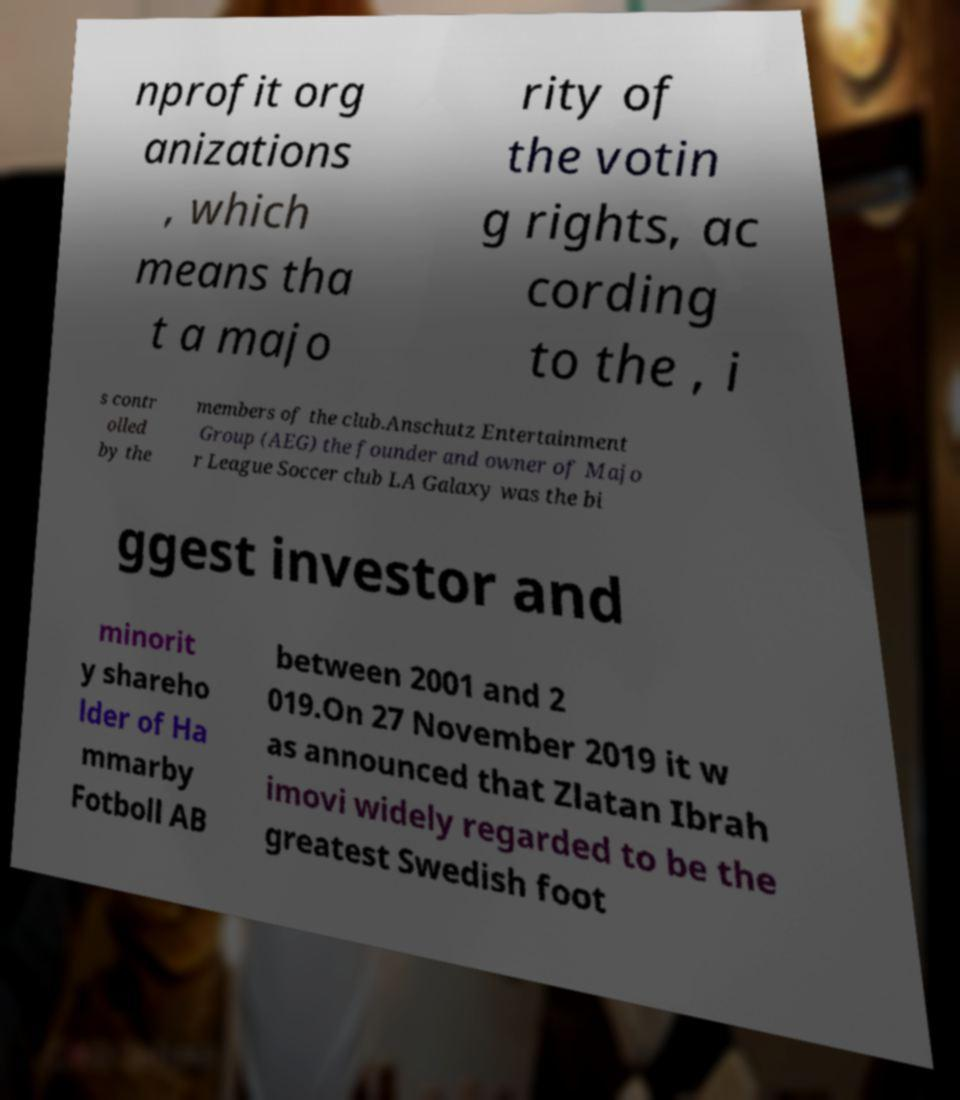Could you extract and type out the text from this image? nprofit org anizations , which means tha t a majo rity of the votin g rights, ac cording to the , i s contr olled by the members of the club.Anschutz Entertainment Group (AEG) the founder and owner of Majo r League Soccer club LA Galaxy was the bi ggest investor and minorit y shareho lder of Ha mmarby Fotboll AB between 2001 and 2 019.On 27 November 2019 it w as announced that Zlatan Ibrah imovi widely regarded to be the greatest Swedish foot 